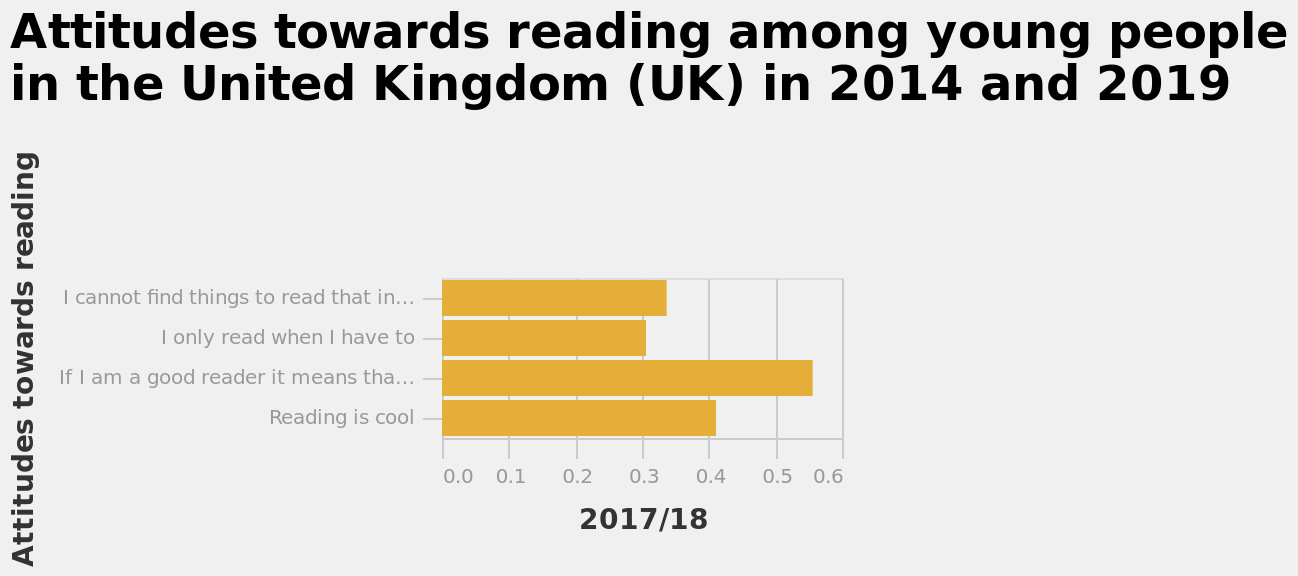<image>
What does the y-axis represent in the bar graph?  The y-axis of the bar graph represents "Attitudes towards reading." 